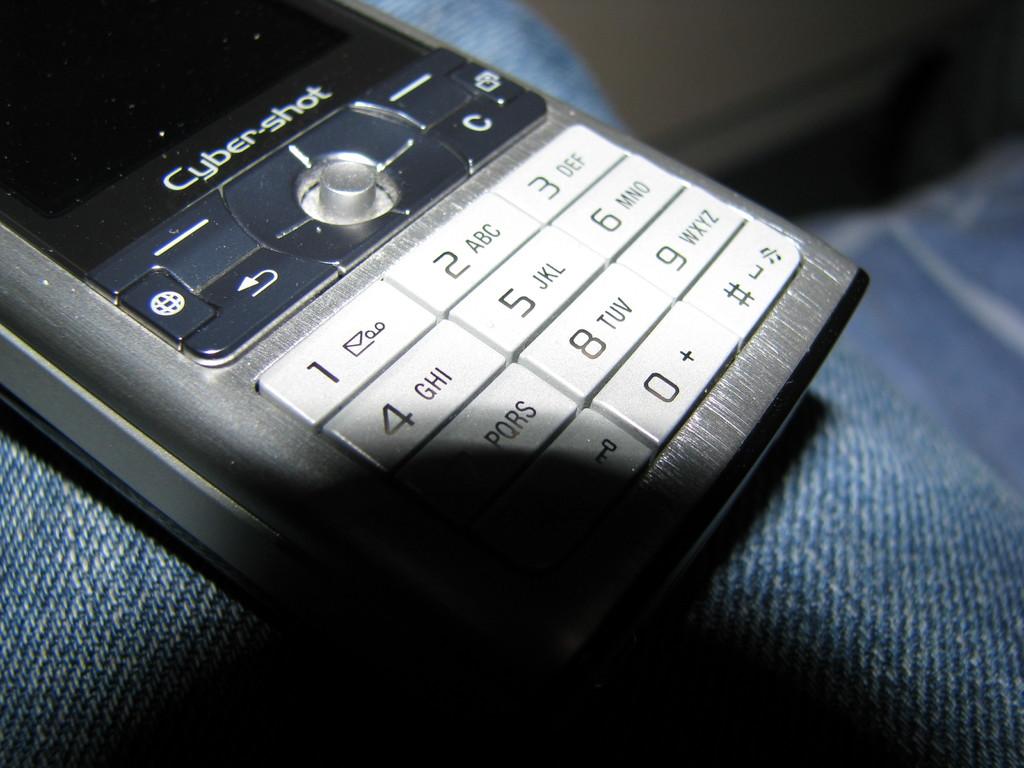What type of phone is this?
Your answer should be compact. Cyber-shot. What number is below the arrow?
Offer a very short reply. 1. 